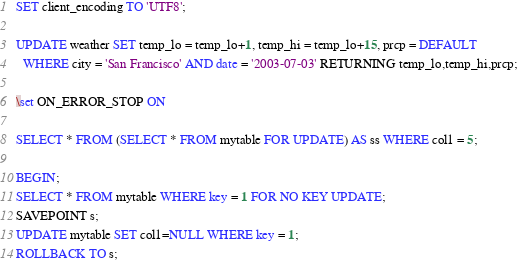Convert code to text. <code><loc_0><loc_0><loc_500><loc_500><_SQL_>SET client_encoding TO 'UTF8';

UPDATE weather SET temp_lo = temp_lo+1, temp_hi = temp_lo+15, prcp = DEFAULT
  WHERE city = 'San Francisco' AND date = '2003-07-03' RETURNING temp_lo,temp_hi,prcp;

\set ON_ERROR_STOP ON

SELECT * FROM (SELECT * FROM mytable FOR UPDATE) AS ss WHERE col1 = 5;

BEGIN;
SELECT * FROM mytable WHERE key = 1 FOR NO KEY UPDATE;
SAVEPOINT s;
UPDATE mytable SET col1=NULL WHERE key = 1;
ROLLBACK TO s;

</code> 